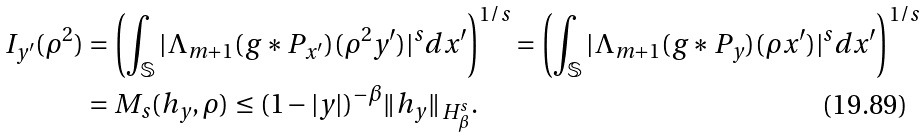<formula> <loc_0><loc_0><loc_500><loc_500>I _ { y ^ { \prime } } ( \rho ^ { 2 } ) & = \left ( \int _ { \mathbb { S } } | \Lambda _ { m + 1 } ( g \ast P _ { x ^ { \prime } } ) ( \rho ^ { 2 } y ^ { \prime } ) | ^ { s } d x ^ { \prime } \right ) ^ { 1 / s } = \left ( \int _ { \mathbb { S } } | \Lambda _ { m + 1 } ( g \ast P _ { y } ) ( \rho x ^ { \prime } ) | ^ { s } d x ^ { \prime } \right ) ^ { 1 / s } \\ & = M _ { s } ( h _ { y } , \rho ) \leq ( 1 - | y | ) ^ { - \beta } \| h _ { y } \| _ { H ^ { s } _ { \beta } } .</formula> 